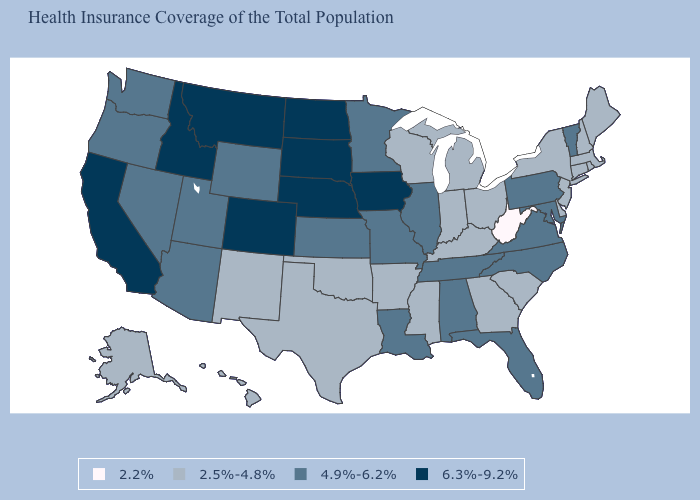What is the lowest value in the West?
Concise answer only. 2.5%-4.8%. Does Virginia have a higher value than Alaska?
Answer briefly. Yes. How many symbols are there in the legend?
Be succinct. 4. Which states have the highest value in the USA?
Keep it brief. California, Colorado, Idaho, Iowa, Montana, Nebraska, North Dakota, South Dakota. What is the value of Tennessee?
Short answer required. 4.9%-6.2%. Among the states that border Ohio , does West Virginia have the highest value?
Write a very short answer. No. What is the value of Maryland?
Short answer required. 4.9%-6.2%. What is the value of Colorado?
Quick response, please. 6.3%-9.2%. What is the highest value in the USA?
Give a very brief answer. 6.3%-9.2%. Name the states that have a value in the range 2.2%?
Short answer required. West Virginia. What is the lowest value in the USA?
Short answer required. 2.2%. Which states have the lowest value in the Northeast?
Give a very brief answer. Connecticut, Maine, Massachusetts, New Hampshire, New Jersey, New York, Rhode Island. Does Oklahoma have the highest value in the South?
Answer briefly. No. Does the first symbol in the legend represent the smallest category?
Give a very brief answer. Yes. What is the highest value in states that border Georgia?
Keep it brief. 4.9%-6.2%. 